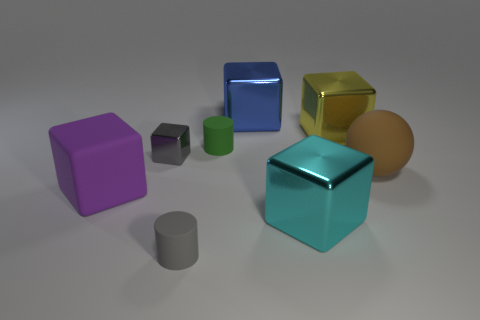Subtract all spheres. How many objects are left? 7 Add 1 tiny purple metallic things. How many objects exist? 9 Subtract all yellow cubes. How many cubes are left? 4 Subtract all large rubber cubes. How many cubes are left? 4 Subtract 0 red cylinders. How many objects are left? 8 Subtract all cyan cylinders. Subtract all red blocks. How many cylinders are left? 2 Subtract all cyan cylinders. How many purple cubes are left? 1 Subtract all tiny green matte cylinders. Subtract all large purple things. How many objects are left? 6 Add 1 large yellow blocks. How many large yellow blocks are left? 2 Add 6 tiny matte cylinders. How many tiny matte cylinders exist? 8 